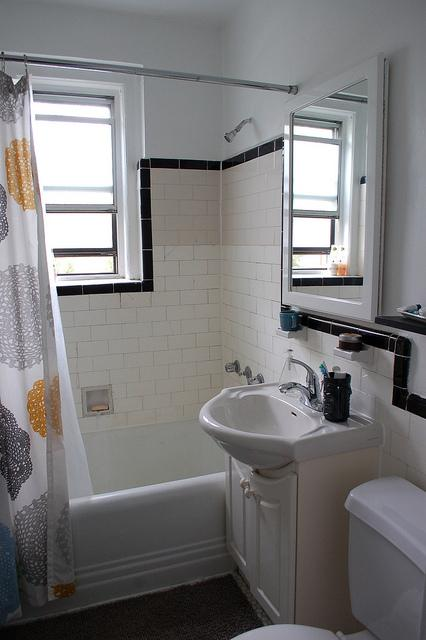What is one of the colors on the curtain? yellow 